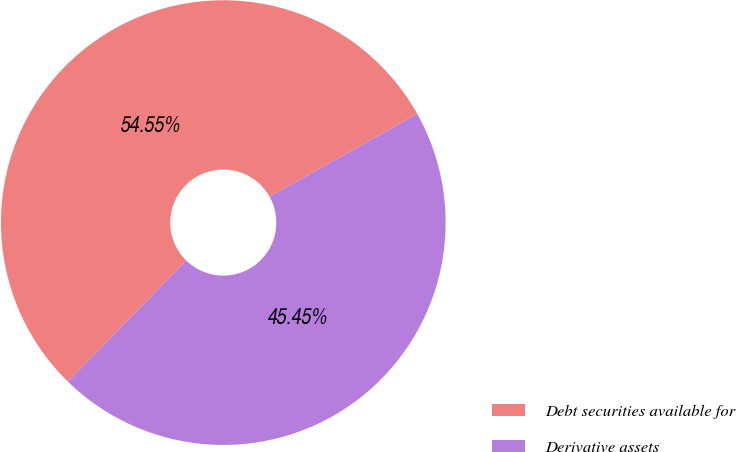Convert chart. <chart><loc_0><loc_0><loc_500><loc_500><pie_chart><fcel>Debt securities available for<fcel>Derivative assets<nl><fcel>54.55%<fcel>45.45%<nl></chart> 